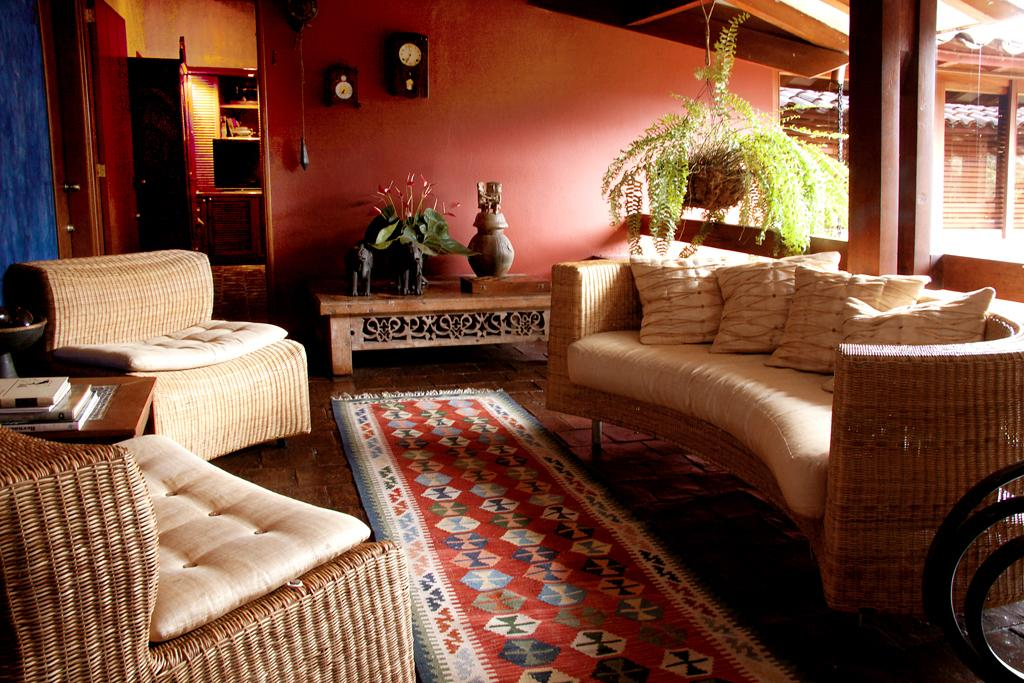What type of furniture is present in the image? There are sofas in the image. What decorative element can be seen in the image? There is a flower in the image. What is hanging on the wall in the image? There is a clock on the wall in the image. What is the table in the image used for? The wheels and books are on the table in the image. What is the purpose of the door in the image? The door in the image provides access to another room or area. What type of floor covering is present in the image? There is a carpet in the image. What type of cork is used to hold the flower in the image? There is no cork present in the image; the flower is not attached to anything. What type of yoke is used to connect the wheels on the table in the image? There is no yoke present in the image; the wheels are not connected to anything. 